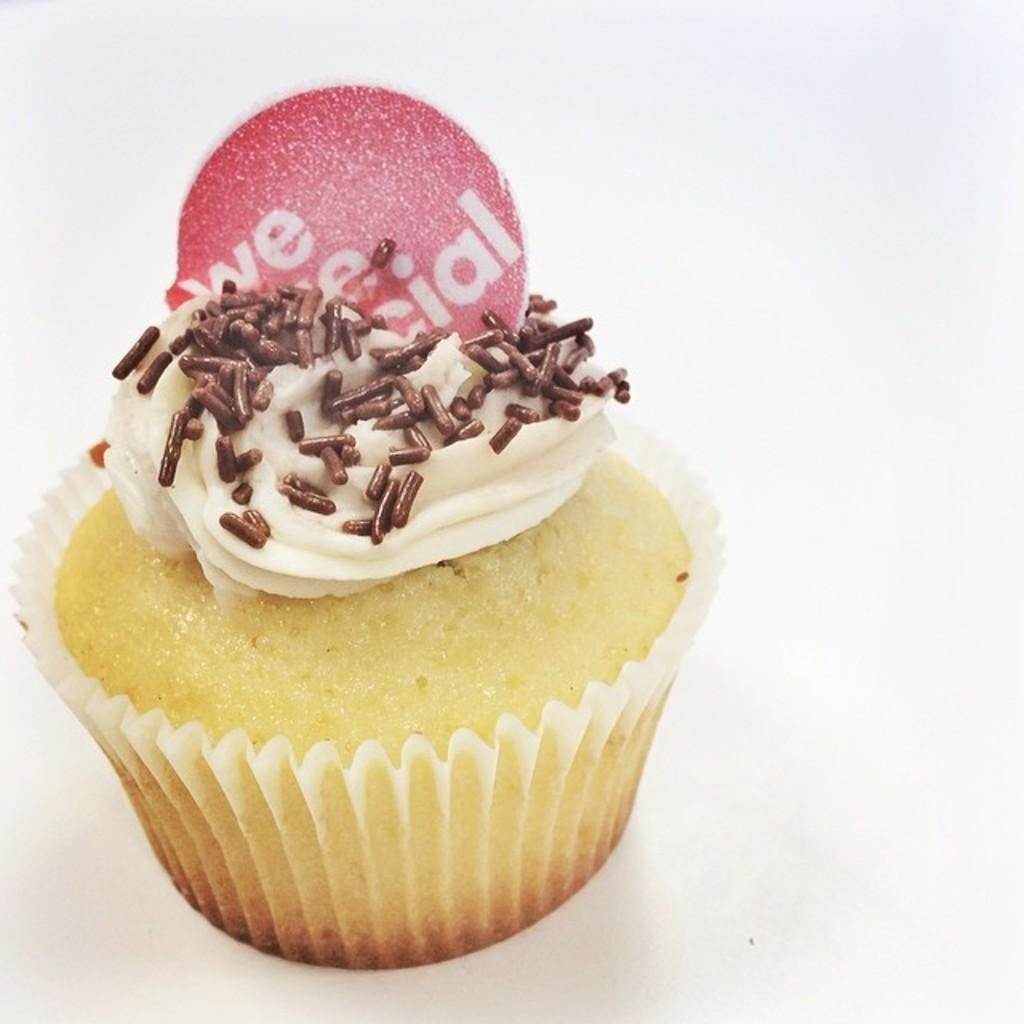What type of dessert is featured in the image? There is a cupcake in the image. What is on top of the cupcake? There is cream on the cupcake. What is the opinion of the desk about the oatmeal in the image? There is no desk or oatmeal present in the image, so it is not possible to determine the opinion of a desk about the image. 